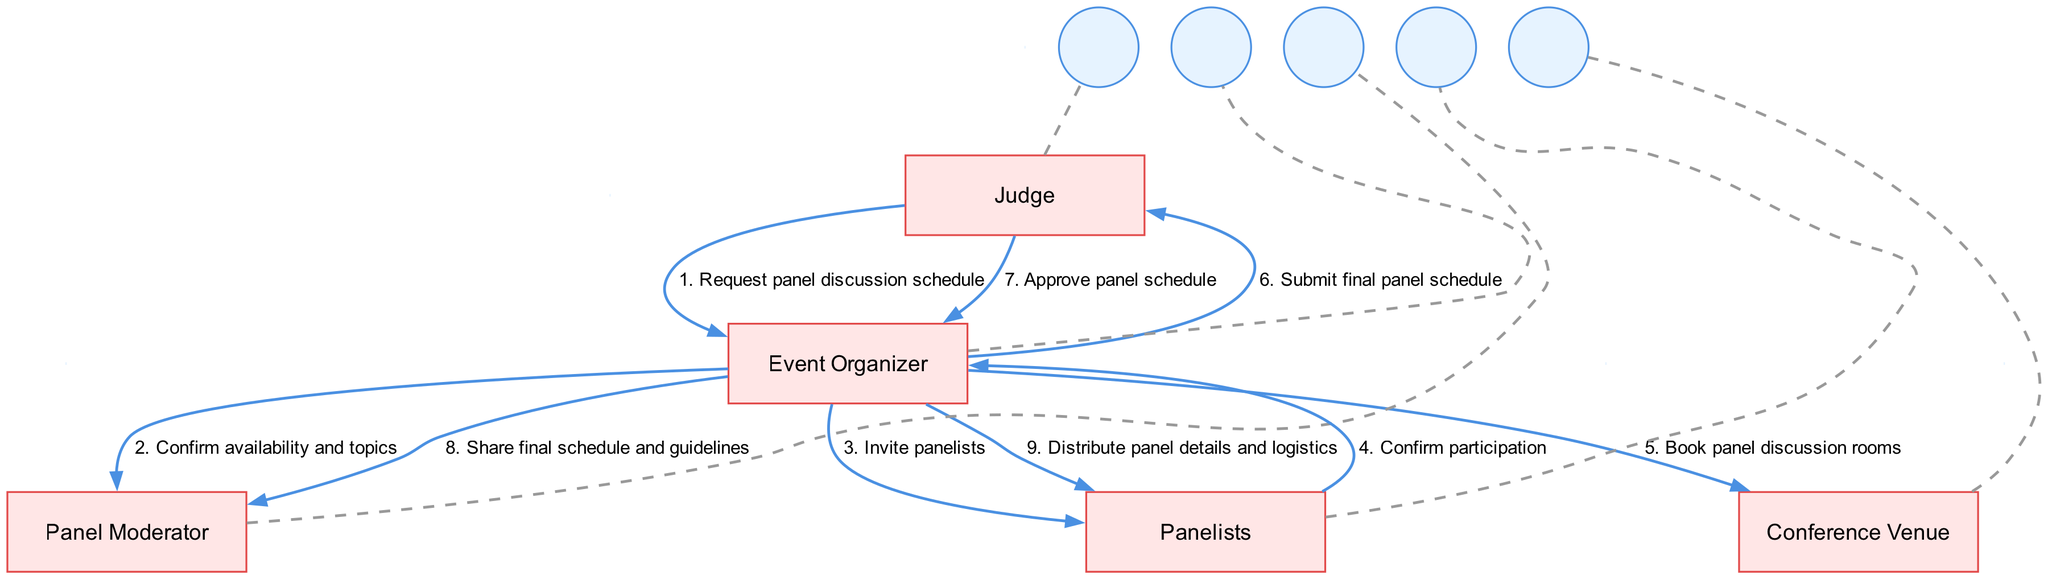What is the first message sent in the sequence? The first message in the sequence is "Request panel discussion schedule," sent from the Judge to the Event Organizer.
Answer: Request panel discussion schedule How many actors are involved in the diagram? The diagram lists five actors: Judge, Event Organizer, Panel Moderator, Panelists, and Conference Venue. Therefore, the total number of actors involved is five.
Answer: 5 Who confirms the availability and topics? The Event Organizer is responsible for confirming the availability and topics with the Panel Moderator.
Answer: Panel Moderator What is the last message sent in the sequence? The last message in the sequence is "Distribute panel details and logistics," sent from the Event Organizer to the Panelists.
Answer: Distribute panel details and logistics Which actor sends the final panel schedule to the Judge? The Event Organizer submits the final panel schedule to the Judge.
Answer: Event Organizer How many messages are sent from the Event Organizer? The Event Organizer sends four messages: confirming availability and topics, inviting panelists, submitting the final panel schedule, and distributing panel details and logistics. Therefore, a total of four messages are sent.
Answer: 4 Who is responsible for booking the conference venue? The Event Organizer is responsible for communicating with the Conference Venue to book the panel discussion rooms.
Answer: Event Organizer What do Panelists confirm after receiving the invitation? The Panelists confirm their participation after receiving the invitation from the Event Organizer.
Answer: Confirm participation What role does the Judge play in the scheduling process? The Judge requests the schedule and approves it after receiving the final version from the Event Organizer.
Answer: Requests and approves schedule 